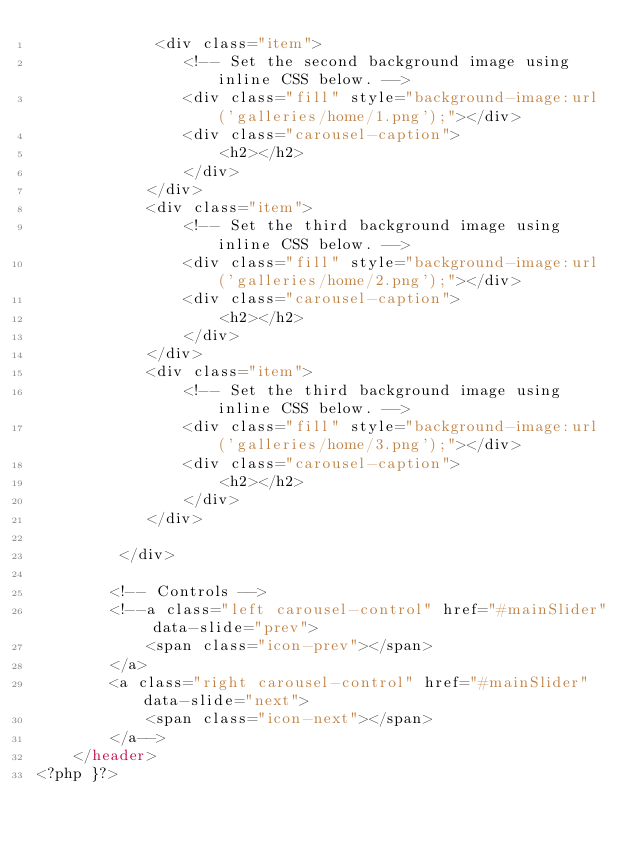Convert code to text. <code><loc_0><loc_0><loc_500><loc_500><_PHP_>             <div class="item">
                <!-- Set the second background image using inline CSS below. -->
                <div class="fill" style="background-image:url('galleries/home/1.png');"></div>
                <div class="carousel-caption">
                    <h2></h2>
                </div>
            </div>
            <div class="item">
                <!-- Set the third background image using inline CSS below. -->
                <div class="fill" style="background-image:url('galleries/home/2.png');"></div>
                <div class="carousel-caption">
                    <h2></h2>
                </div>
            </div>
            <div class="item">
                <!-- Set the third background image using inline CSS below. -->
                <div class="fill" style="background-image:url('galleries/home/3.png');"></div>
                <div class="carousel-caption">
                    <h2></h2>
                </div>
            </div>
            
         </div>

        <!-- Controls -->
        <!--a class="left carousel-control" href="#mainSlider" data-slide="prev">
            <span class="icon-prev"></span>
        </a>
        <a class="right carousel-control" href="#mainSlider" data-slide="next">
            <span class="icon-next"></span>
        </a-->
    </header>
<?php }?></code> 